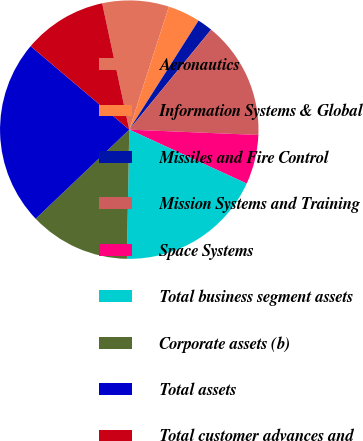<chart> <loc_0><loc_0><loc_500><loc_500><pie_chart><fcel>Aeronautics<fcel>Information Systems & Global<fcel>Missiles and Fire Control<fcel>Mission Systems and Training<fcel>Space Systems<fcel>Total business segment assets<fcel>Corporate assets (b)<fcel>Total assets<fcel>Total customer advances and<nl><fcel>8.32%<fcel>4.05%<fcel>1.91%<fcel>14.74%<fcel>6.19%<fcel>18.44%<fcel>12.6%<fcel>23.29%<fcel>10.46%<nl></chart> 